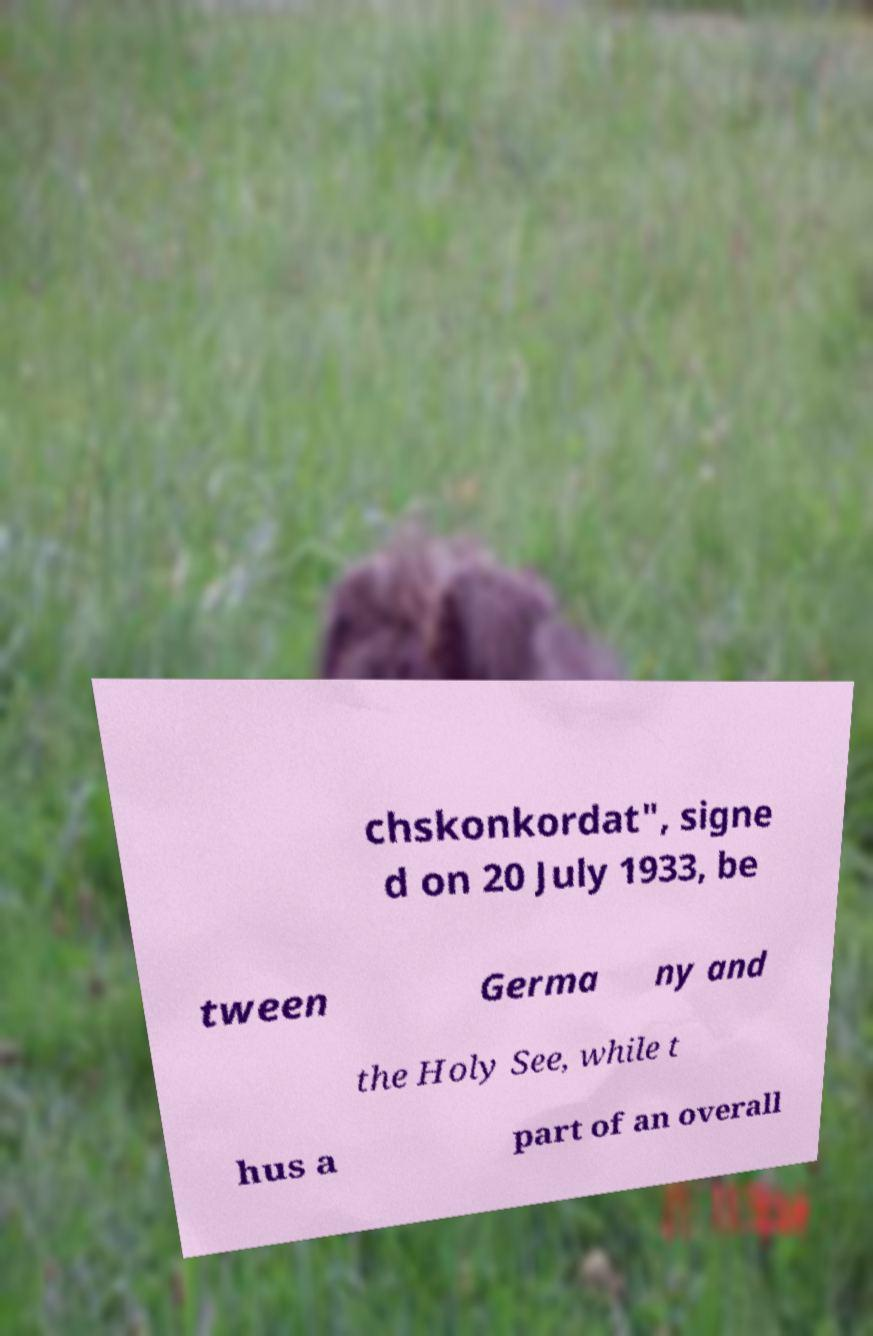Please read and relay the text visible in this image. What does it say? chskonkordat", signe d on 20 July 1933, be tween Germa ny and the Holy See, while t hus a part of an overall 